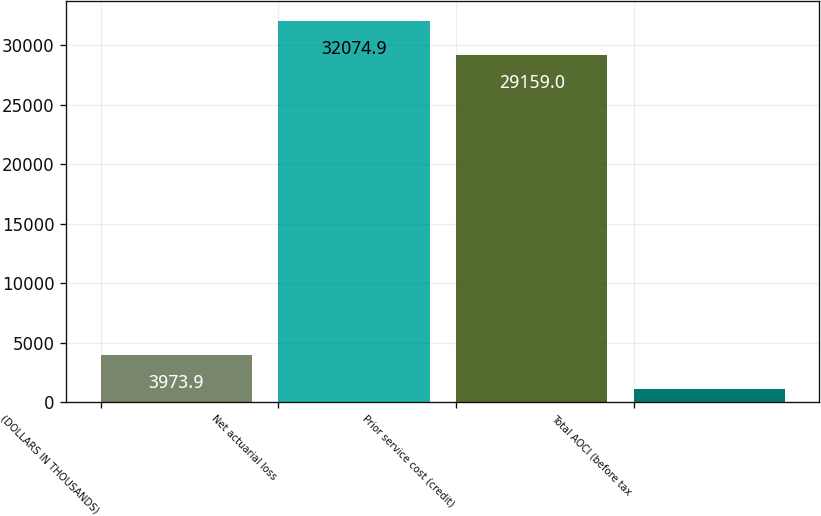Convert chart. <chart><loc_0><loc_0><loc_500><loc_500><bar_chart><fcel>(DOLLARS IN THOUSANDS)<fcel>Net actuarial loss<fcel>Prior service cost (credit)<fcel>Total AOCI (before tax<nl><fcel>3973.9<fcel>32074.9<fcel>29159<fcel>1058<nl></chart> 